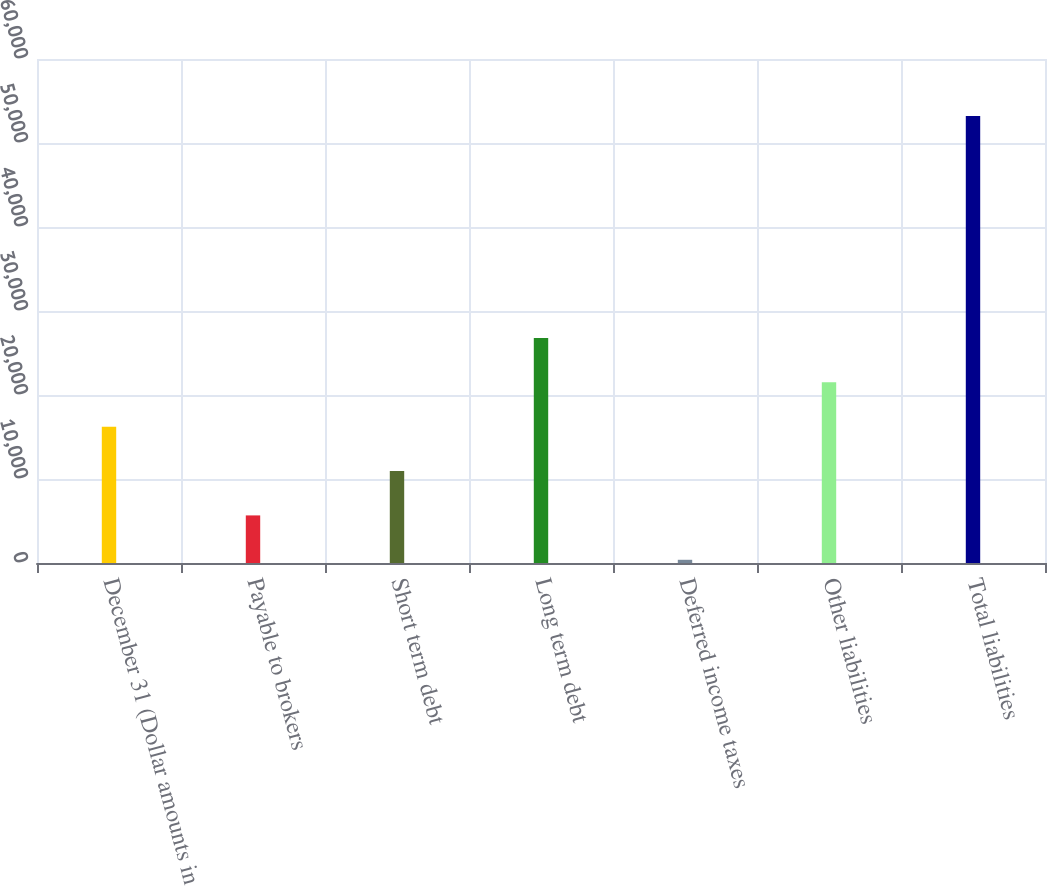Convert chart. <chart><loc_0><loc_0><loc_500><loc_500><bar_chart><fcel>December 31 (Dollar amounts in<fcel>Payable to brokers<fcel>Short term debt<fcel>Long term debt<fcel>Deferred income taxes<fcel>Other liabilities<fcel>Total liabilities<nl><fcel>16233.1<fcel>5665.7<fcel>10949.4<fcel>26800.5<fcel>382<fcel>21516.8<fcel>53219<nl></chart> 